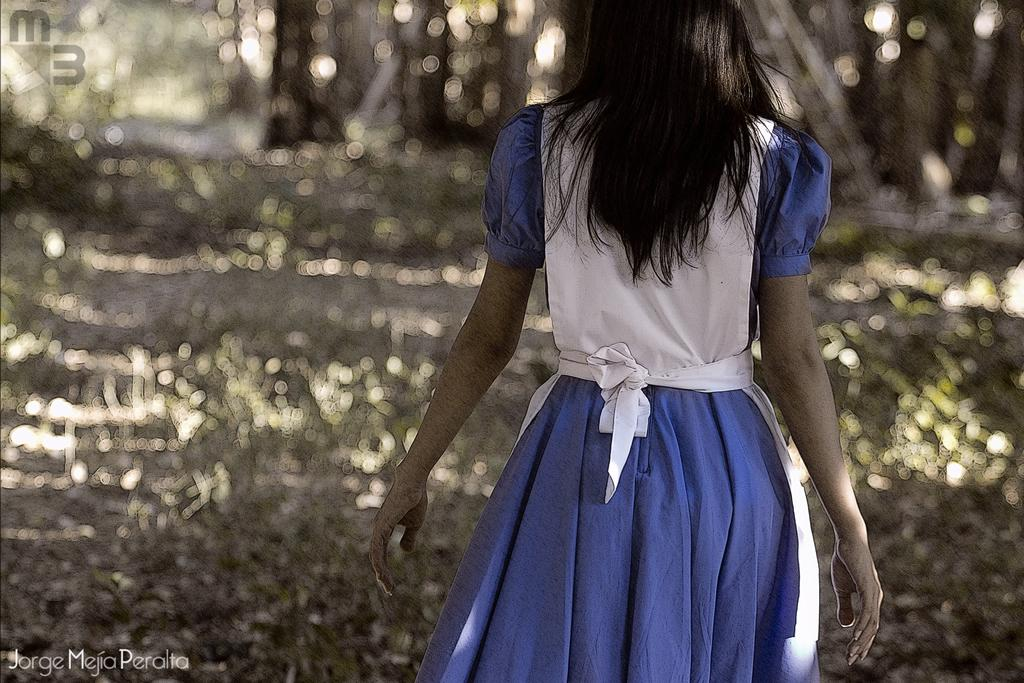Who is the main subject in the foreground of the picture? There is a woman in the foreground of the picture. What is the woman doing in the image? The woman is walking. What can be seen in the background of the image? There are trees in the background of the image. What type of sign can be seen in the woman's hand in the image? There is no sign visible in the woman's hand in the image. What type of sack is the woman carrying on her back in the image? The woman is not carrying a sack on her back in the image. 